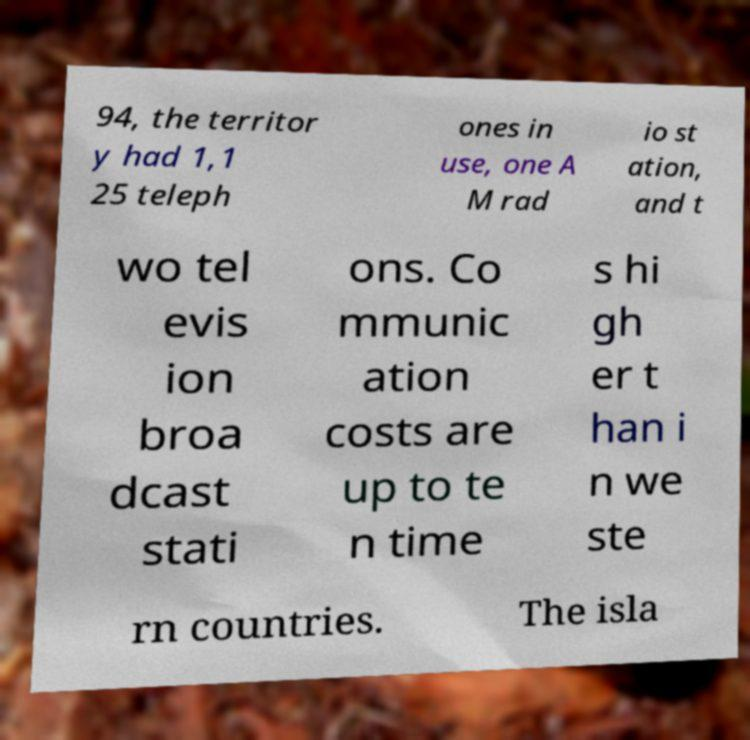Can you read and provide the text displayed in the image?This photo seems to have some interesting text. Can you extract and type it out for me? 94, the territor y had 1,1 25 teleph ones in use, one A M rad io st ation, and t wo tel evis ion broa dcast stati ons. Co mmunic ation costs are up to te n time s hi gh er t han i n we ste rn countries. The isla 